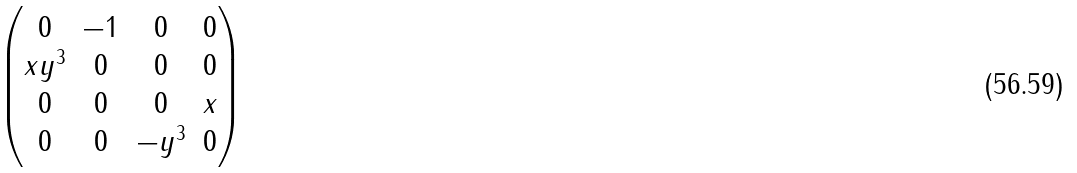<formula> <loc_0><loc_0><loc_500><loc_500>\begin{pmatrix} 0 & - 1 & 0 & 0 \\ x y ^ { 3 } & 0 & 0 & 0 \\ 0 & 0 & 0 & x \\ 0 & 0 & - y ^ { 3 } & 0 \end{pmatrix}</formula> 